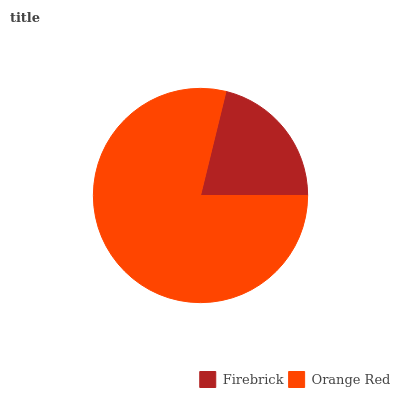Is Firebrick the minimum?
Answer yes or no. Yes. Is Orange Red the maximum?
Answer yes or no. Yes. Is Orange Red the minimum?
Answer yes or no. No. Is Orange Red greater than Firebrick?
Answer yes or no. Yes. Is Firebrick less than Orange Red?
Answer yes or no. Yes. Is Firebrick greater than Orange Red?
Answer yes or no. No. Is Orange Red less than Firebrick?
Answer yes or no. No. Is Orange Red the high median?
Answer yes or no. Yes. Is Firebrick the low median?
Answer yes or no. Yes. Is Firebrick the high median?
Answer yes or no. No. Is Orange Red the low median?
Answer yes or no. No. 